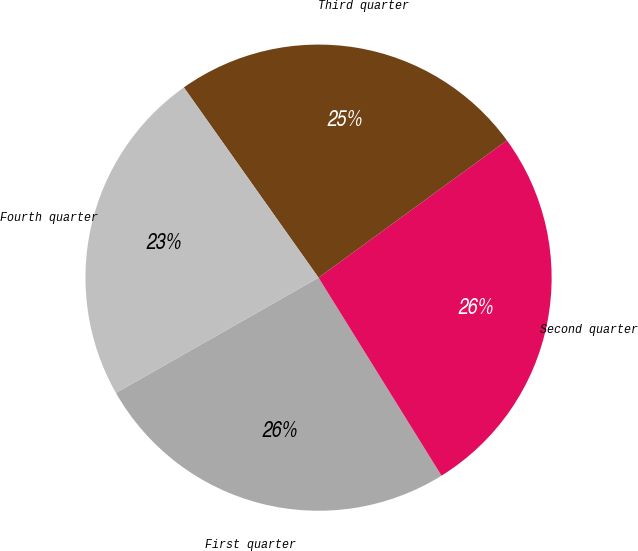<chart> <loc_0><loc_0><loc_500><loc_500><pie_chart><fcel>First quarter<fcel>Second quarter<fcel>Third quarter<fcel>Fourth quarter<nl><fcel>25.61%<fcel>26.18%<fcel>24.78%<fcel>23.43%<nl></chart> 